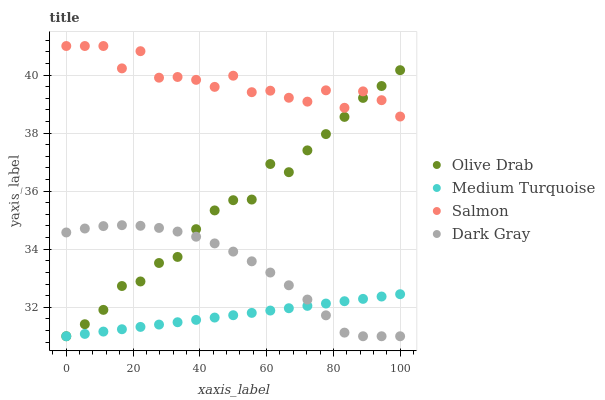Does Medium Turquoise have the minimum area under the curve?
Answer yes or no. Yes. Does Salmon have the maximum area under the curve?
Answer yes or no. Yes. Does Salmon have the minimum area under the curve?
Answer yes or no. No. Does Medium Turquoise have the maximum area under the curve?
Answer yes or no. No. Is Medium Turquoise the smoothest?
Answer yes or no. Yes. Is Salmon the roughest?
Answer yes or no. Yes. Is Salmon the smoothest?
Answer yes or no. No. Is Medium Turquoise the roughest?
Answer yes or no. No. Does Dark Gray have the lowest value?
Answer yes or no. Yes. Does Salmon have the lowest value?
Answer yes or no. No. Does Salmon have the highest value?
Answer yes or no. Yes. Does Medium Turquoise have the highest value?
Answer yes or no. No. Is Medium Turquoise less than Salmon?
Answer yes or no. Yes. Is Salmon greater than Medium Turquoise?
Answer yes or no. Yes. Does Dark Gray intersect Medium Turquoise?
Answer yes or no. Yes. Is Dark Gray less than Medium Turquoise?
Answer yes or no. No. Is Dark Gray greater than Medium Turquoise?
Answer yes or no. No. Does Medium Turquoise intersect Salmon?
Answer yes or no. No. 